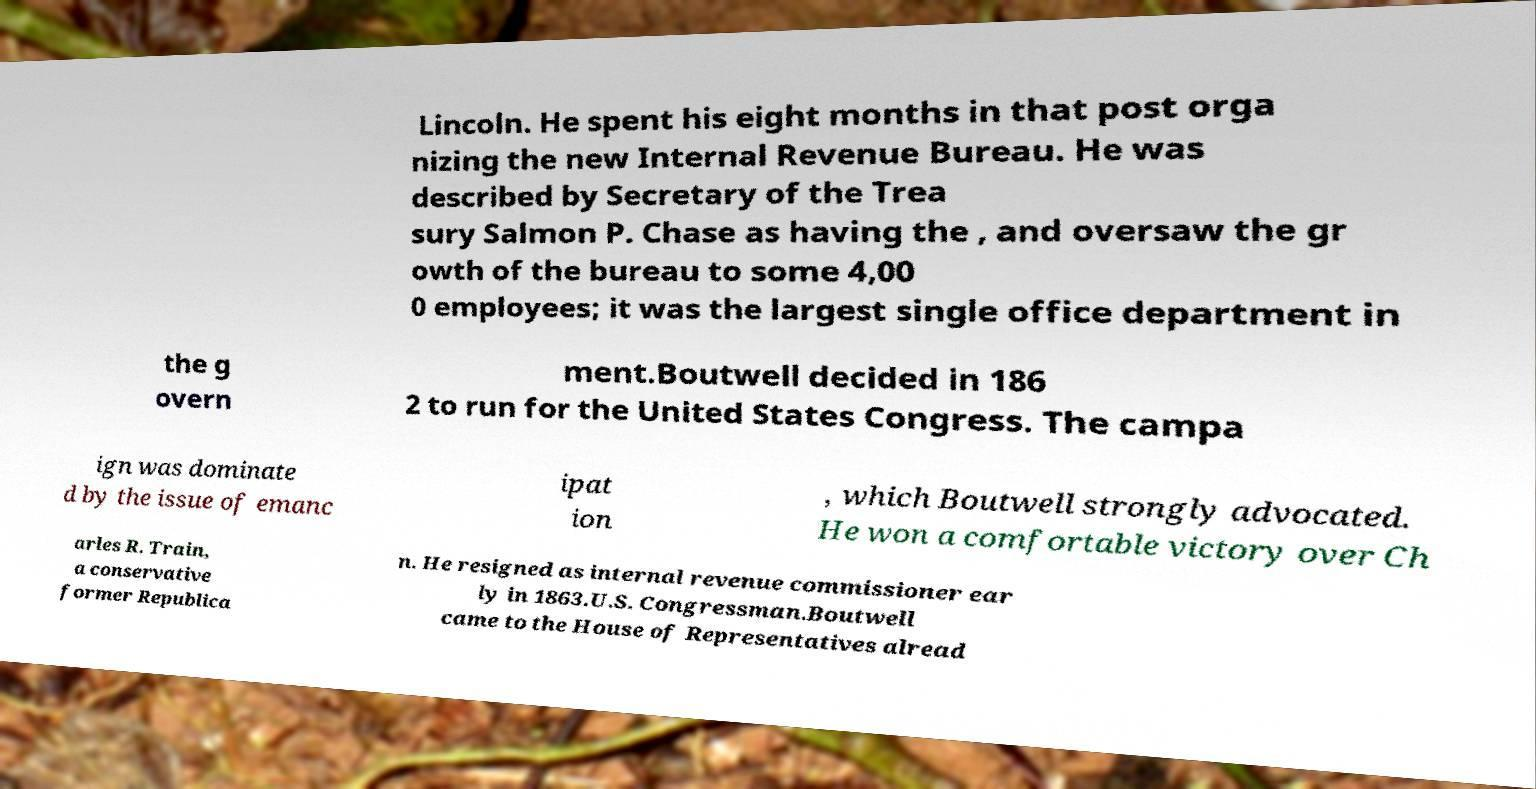What messages or text are displayed in this image? I need them in a readable, typed format. Lincoln. He spent his eight months in that post orga nizing the new Internal Revenue Bureau. He was described by Secretary of the Trea sury Salmon P. Chase as having the , and oversaw the gr owth of the bureau to some 4,00 0 employees; it was the largest single office department in the g overn ment.Boutwell decided in 186 2 to run for the United States Congress. The campa ign was dominate d by the issue of emanc ipat ion , which Boutwell strongly advocated. He won a comfortable victory over Ch arles R. Train, a conservative former Republica n. He resigned as internal revenue commissioner ear ly in 1863.U.S. Congressman.Boutwell came to the House of Representatives alread 